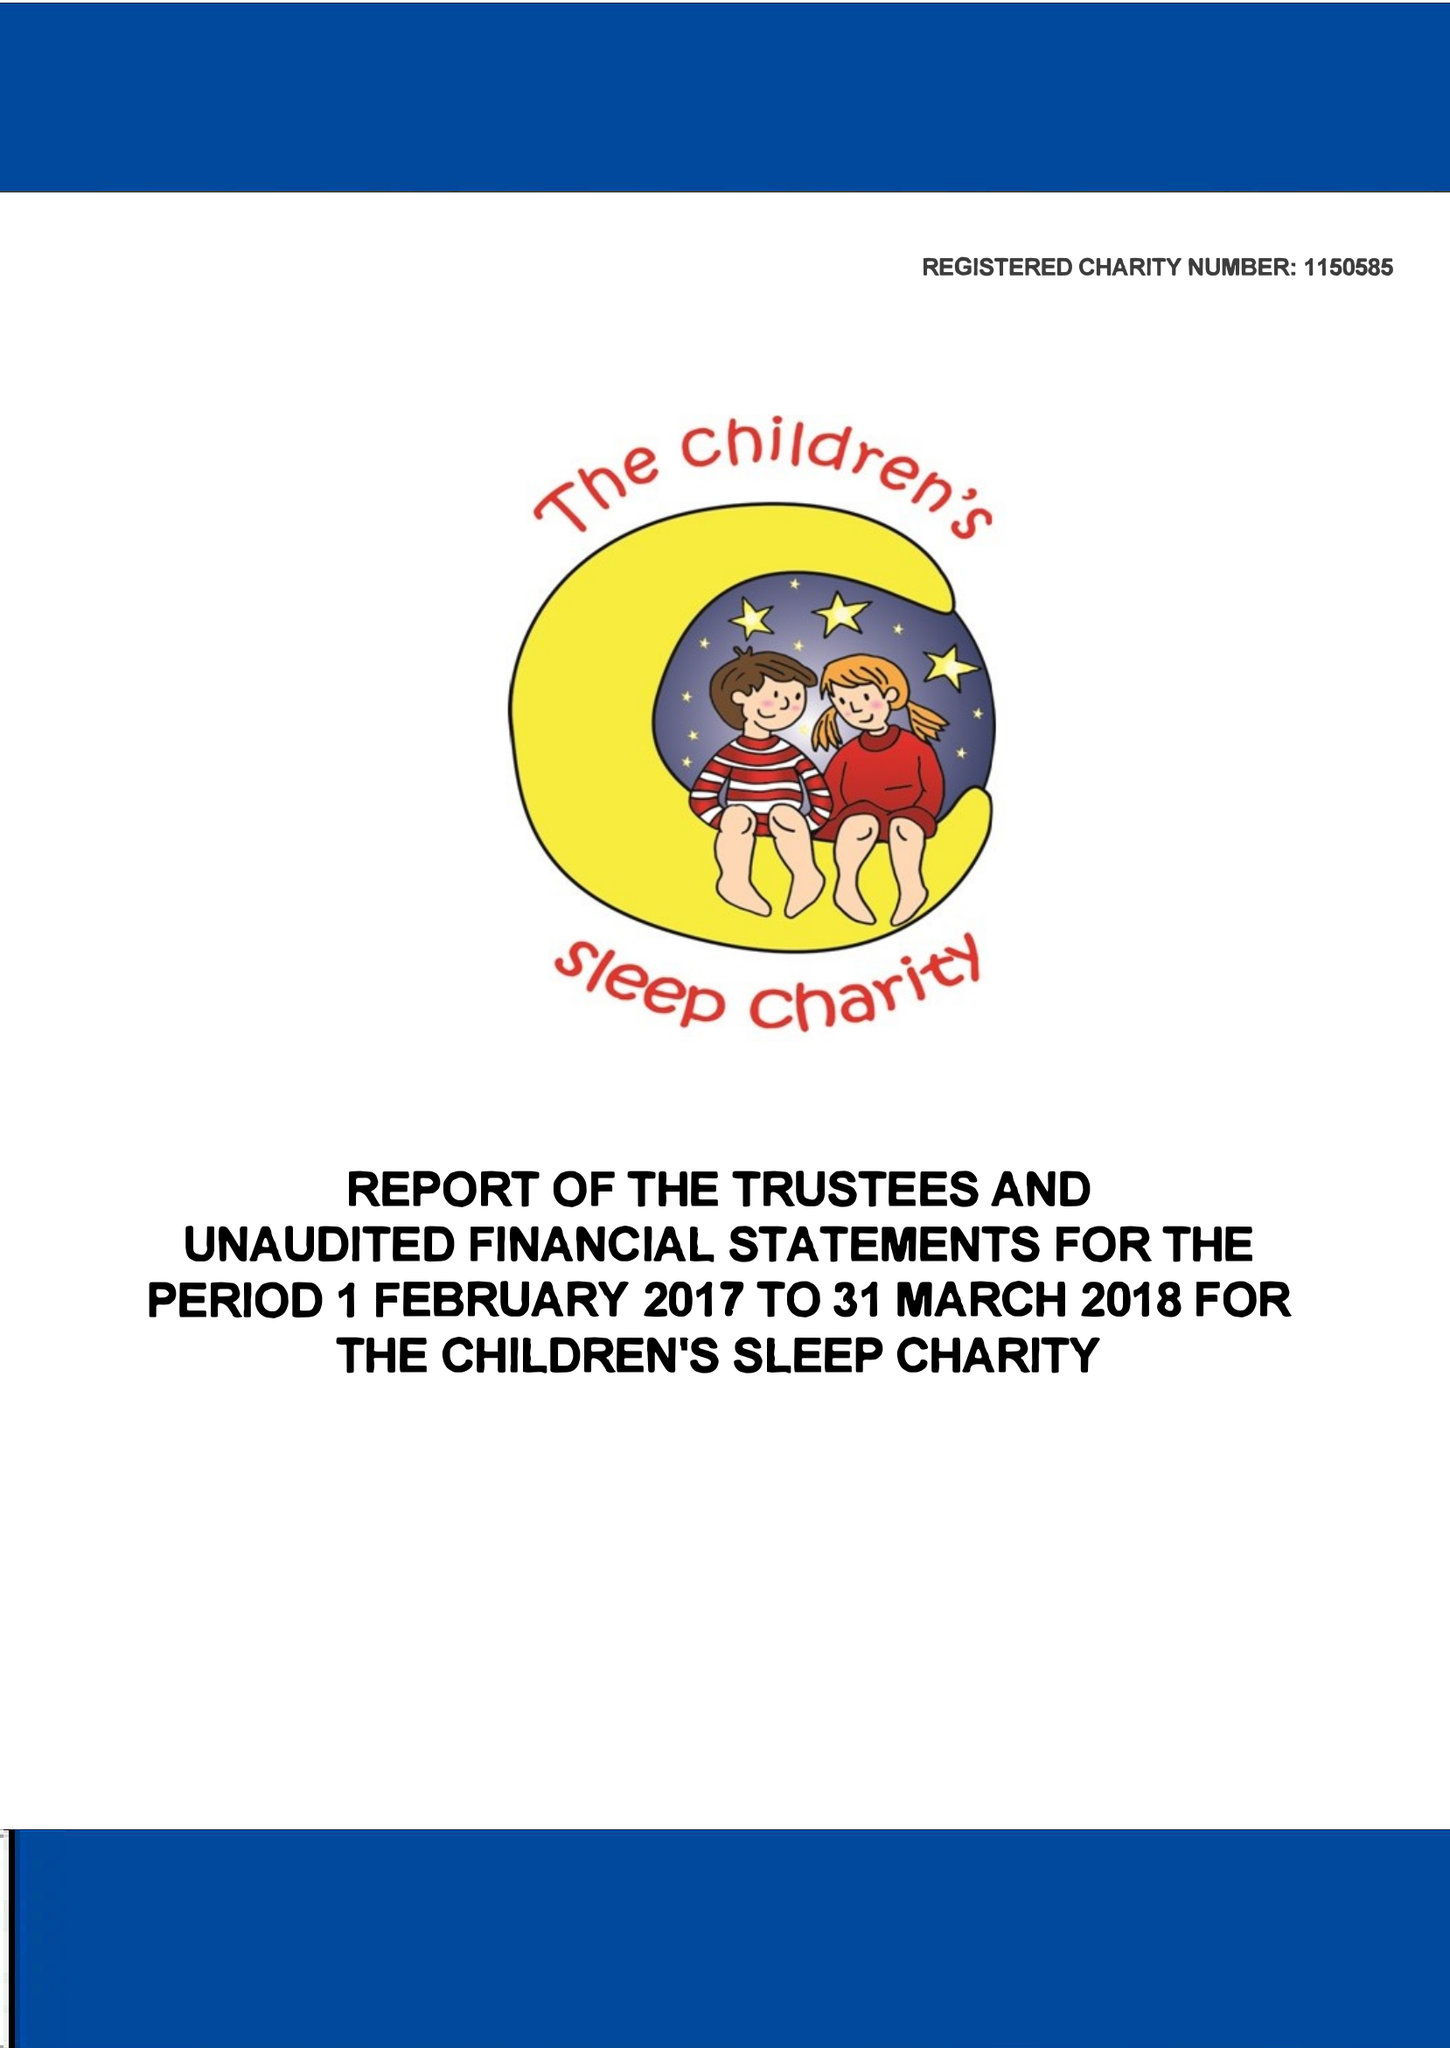What is the value for the charity_number?
Answer the question using a single word or phrase. 1150585 